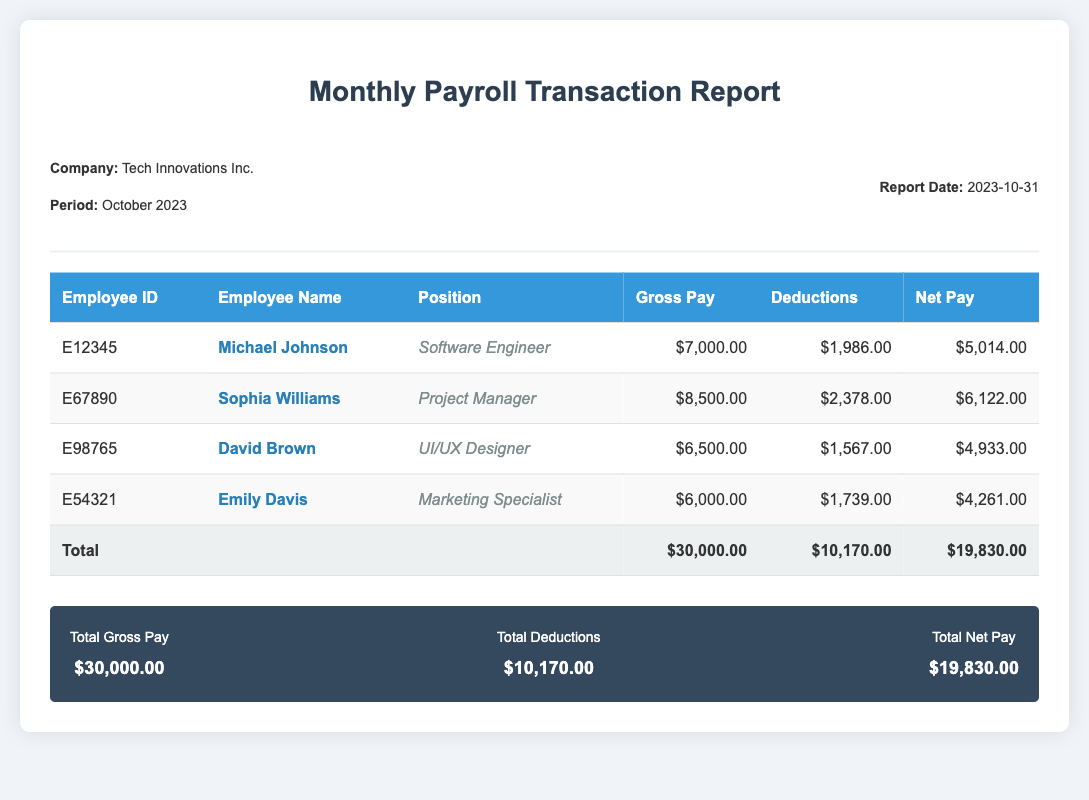What is the period of the report? The period of the report is mentioned in the header, indicating the month and year covered by the payroll.
Answer: October 2023 Who is the Project Manager? The employee's name and position for the Project Manager role are listed in the table.
Answer: Sophia Williams What is the total gross pay for all employees? The total gross pay is computed and displayed in the total row at the bottom of the report.
Answer: $30,000.00 How much are the total deductions? The total deductions are clearly stated in the summary section of the report.
Answer: $10,170.00 What is the net pay for Michael Johnson? The net pay for Michael Johnson is provided in the corresponding row of the payroll table.
Answer: $5,014.00 How many employees were listed in the report? The number of employees can be determined by counting the rows in the payroll section, excluding the header and total.
Answer: 4 What position does David Brown hold? David Brown's position is specified in the table under his name.
Answer: UI/UX Designer What is the report date? The report date is stated in the header section of the document.
Answer: 2023-10-31 What is the highest gross pay recorded? The highest gross pay can be inferred from the gross pay figures provided for employees.
Answer: $8,500.00 